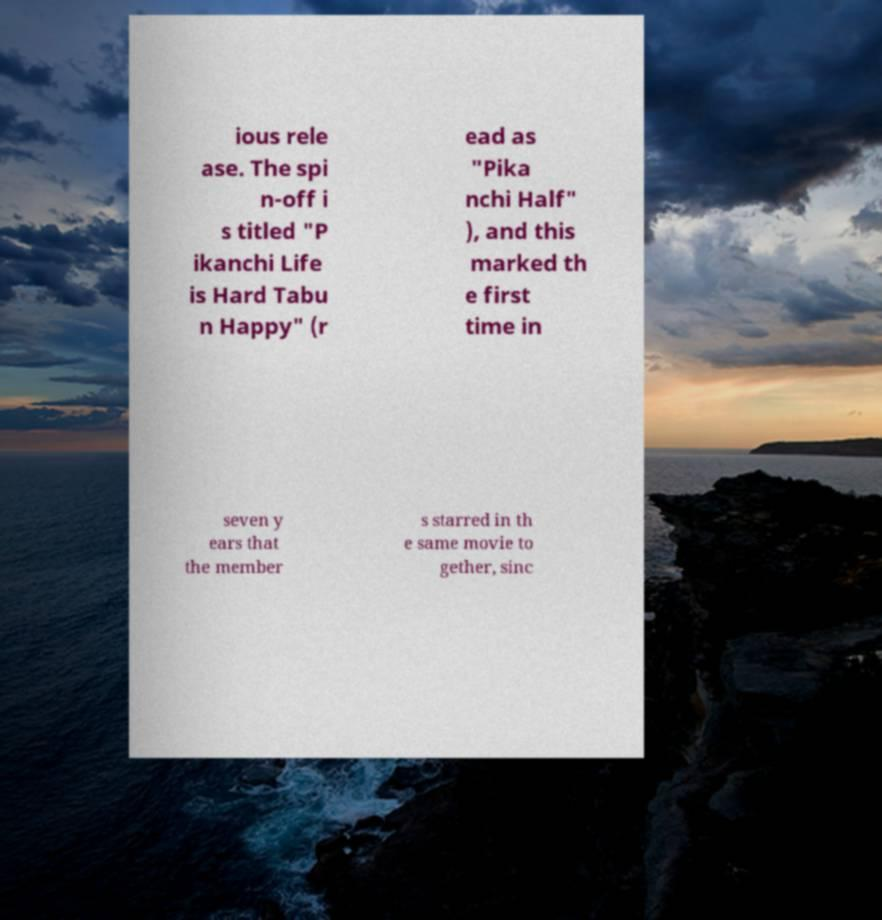What messages or text are displayed in this image? I need them in a readable, typed format. ious rele ase. The spi n-off i s titled "P ikanchi Life is Hard Tabu n Happy" (r ead as "Pika nchi Half" ), and this marked th e first time in seven y ears that the member s starred in th e same movie to gether, sinc 